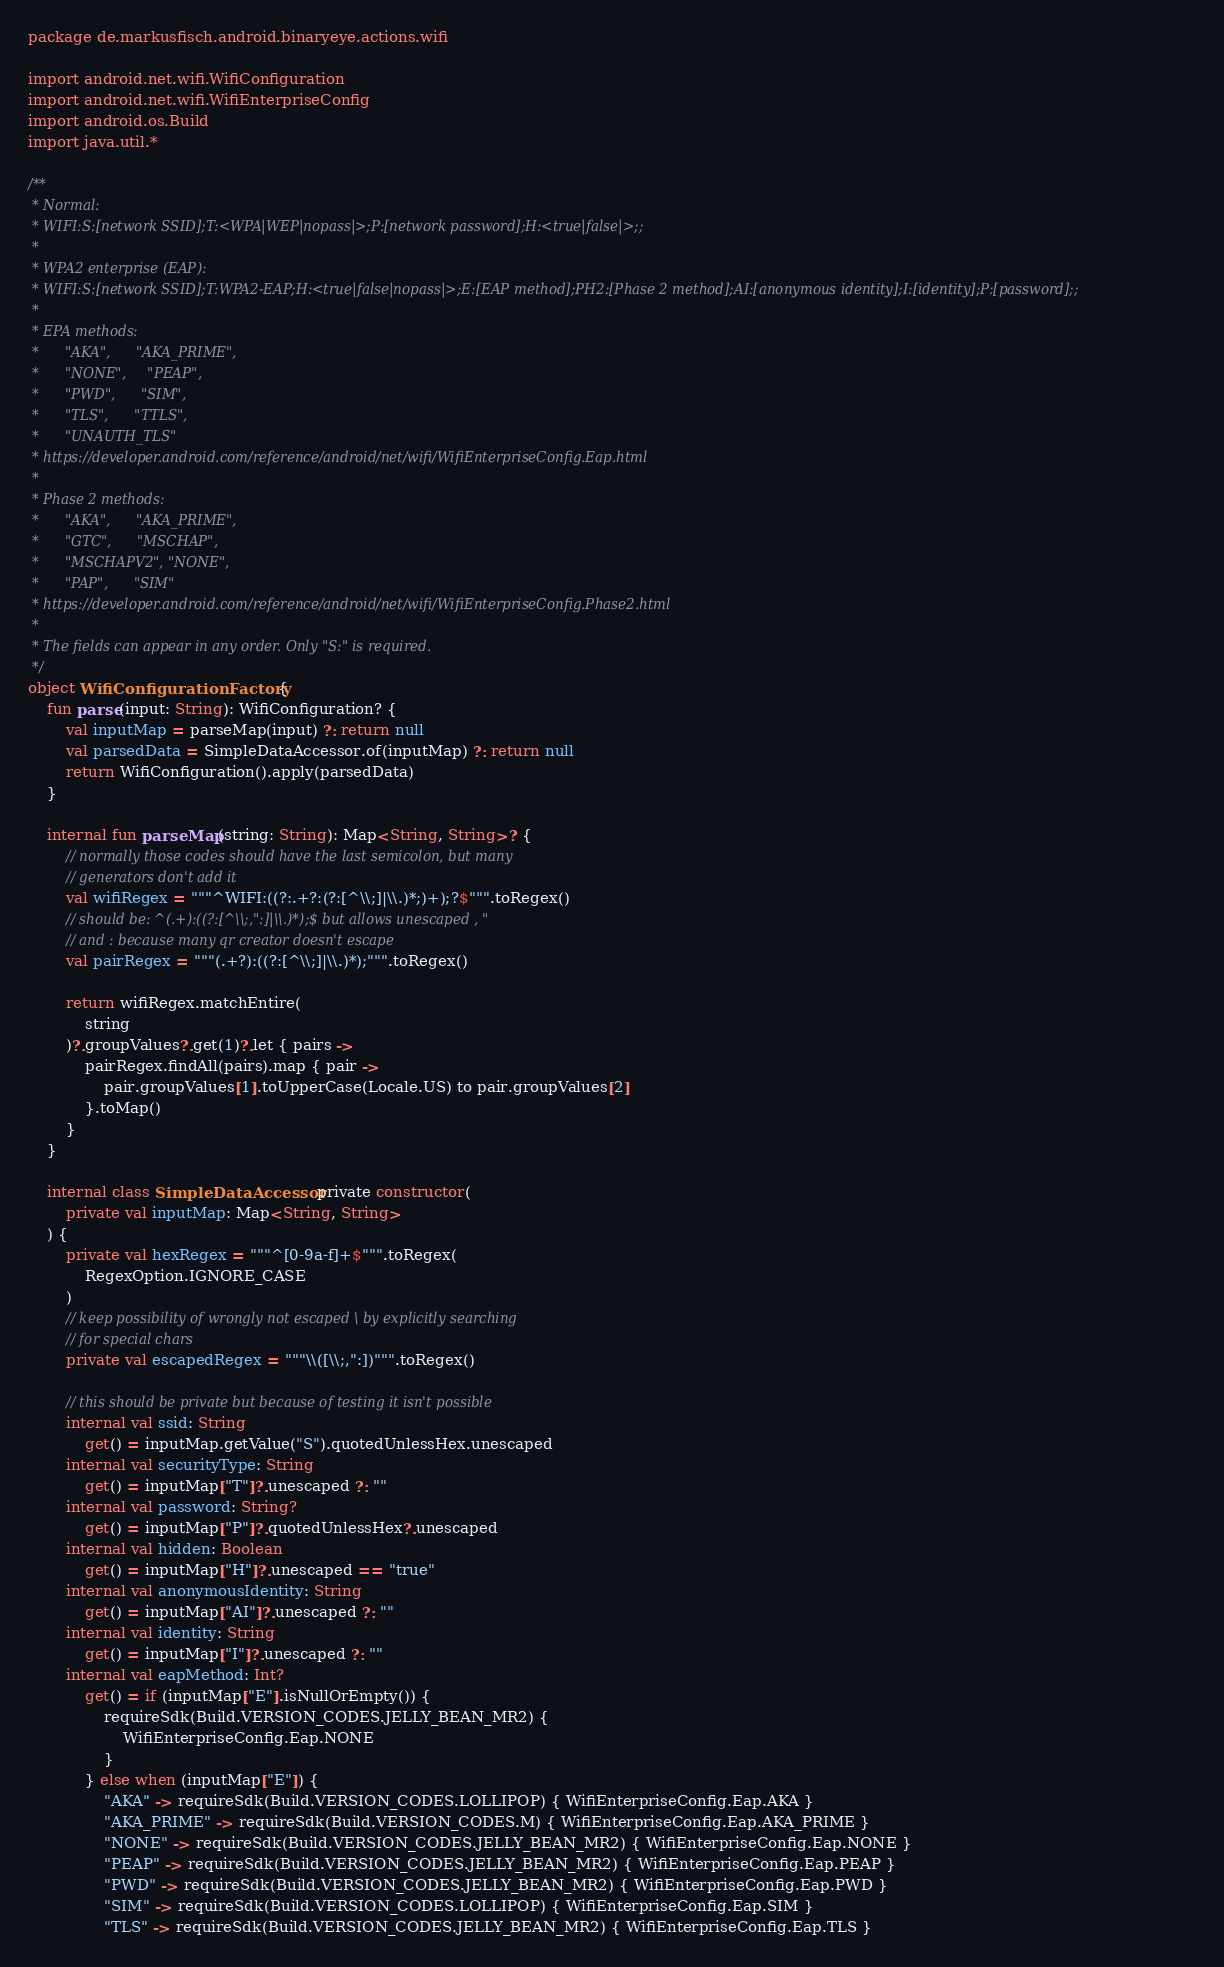Convert code to text. <code><loc_0><loc_0><loc_500><loc_500><_Kotlin_>package de.markusfisch.android.binaryeye.actions.wifi

import android.net.wifi.WifiConfiguration
import android.net.wifi.WifiEnterpriseConfig
import android.os.Build
import java.util.*

/**
 * Normal:
 * WIFI:S:[network SSID];T:<WPA|WEP|nopass|>;P:[network password];H:<true|false|>;;
 *
 * WPA2 enterprise (EAP):
 * WIFI:S:[network SSID];T:WPA2-EAP;H:<true|false|nopass|>;E:[EAP method];PH2:[Phase 2 method];AI:[anonymous identity];I:[identity];P:[password];;
 *
 * EPA methods:
 *      "AKA",      "AKA_PRIME",
 *      "NONE",     "PEAP",
 *      "PWD",      "SIM",
 *      "TLS",      "TTLS",
 *      "UNAUTH_TLS"
 * https://developer.android.com/reference/android/net/wifi/WifiEnterpriseConfig.Eap.html
 *
 * Phase 2 methods:
 *      "AKA",      "AKA_PRIME",
 *      "GTC",      "MSCHAP",
 *      "MSCHAPV2", "NONE",
 *      "PAP",      "SIM"
 * https://developer.android.com/reference/android/net/wifi/WifiEnterpriseConfig.Phase2.html
 *
 * The fields can appear in any order. Only "S:" is required.
 */
object WifiConfigurationFactory {
	fun parse(input: String): WifiConfiguration? {
		val inputMap = parseMap(input) ?: return null
		val parsedData = SimpleDataAccessor.of(inputMap) ?: return null
		return WifiConfiguration().apply(parsedData)
	}

	internal fun parseMap(string: String): Map<String, String>? {
		// normally those codes should have the last semicolon, but many
		// generators don't add it
		val wifiRegex = """^WIFI:((?:.+?:(?:[^\\;]|\\.)*;)+);?$""".toRegex()
		// should be: ^(.+):((?:[^\\;,":]|\\.)*);$ but allows unescaped , "
		// and : because many qr creator doesn't escape
		val pairRegex = """(.+?):((?:[^\\;]|\\.)*);""".toRegex()

		return wifiRegex.matchEntire(
			string
		)?.groupValues?.get(1)?.let { pairs ->
			pairRegex.findAll(pairs).map { pair ->
				pair.groupValues[1].toUpperCase(Locale.US) to pair.groupValues[2]
			}.toMap()
		}
	}

	internal class SimpleDataAccessor private constructor(
		private val inputMap: Map<String, String>
	) {
		private val hexRegex = """^[0-9a-f]+$""".toRegex(
			RegexOption.IGNORE_CASE
		)
		// keep possibility of wrongly not escaped \ by explicitly searching
		// for special chars
		private val escapedRegex = """\\([\\;,":])""".toRegex()

		// this should be private but because of testing it isn't possible
		internal val ssid: String
			get() = inputMap.getValue("S").quotedUnlessHex.unescaped
		internal val securityType: String
			get() = inputMap["T"]?.unescaped ?: ""
		internal val password: String?
			get() = inputMap["P"]?.quotedUnlessHex?.unescaped
		internal val hidden: Boolean
			get() = inputMap["H"]?.unescaped == "true"
		internal val anonymousIdentity: String
			get() = inputMap["AI"]?.unescaped ?: ""
		internal val identity: String
			get() = inputMap["I"]?.unescaped ?: ""
		internal val eapMethod: Int?
			get() = if (inputMap["E"].isNullOrEmpty()) {
				requireSdk(Build.VERSION_CODES.JELLY_BEAN_MR2) {
					WifiEnterpriseConfig.Eap.NONE
				}
			} else when (inputMap["E"]) {
				"AKA" -> requireSdk(Build.VERSION_CODES.LOLLIPOP) { WifiEnterpriseConfig.Eap.AKA }
				"AKA_PRIME" -> requireSdk(Build.VERSION_CODES.M) { WifiEnterpriseConfig.Eap.AKA_PRIME }
				"NONE" -> requireSdk(Build.VERSION_CODES.JELLY_BEAN_MR2) { WifiEnterpriseConfig.Eap.NONE }
				"PEAP" -> requireSdk(Build.VERSION_CODES.JELLY_BEAN_MR2) { WifiEnterpriseConfig.Eap.PEAP }
				"PWD" -> requireSdk(Build.VERSION_CODES.JELLY_BEAN_MR2) { WifiEnterpriseConfig.Eap.PWD }
				"SIM" -> requireSdk(Build.VERSION_CODES.LOLLIPOP) { WifiEnterpriseConfig.Eap.SIM }
				"TLS" -> requireSdk(Build.VERSION_CODES.JELLY_BEAN_MR2) { WifiEnterpriseConfig.Eap.TLS }</code> 